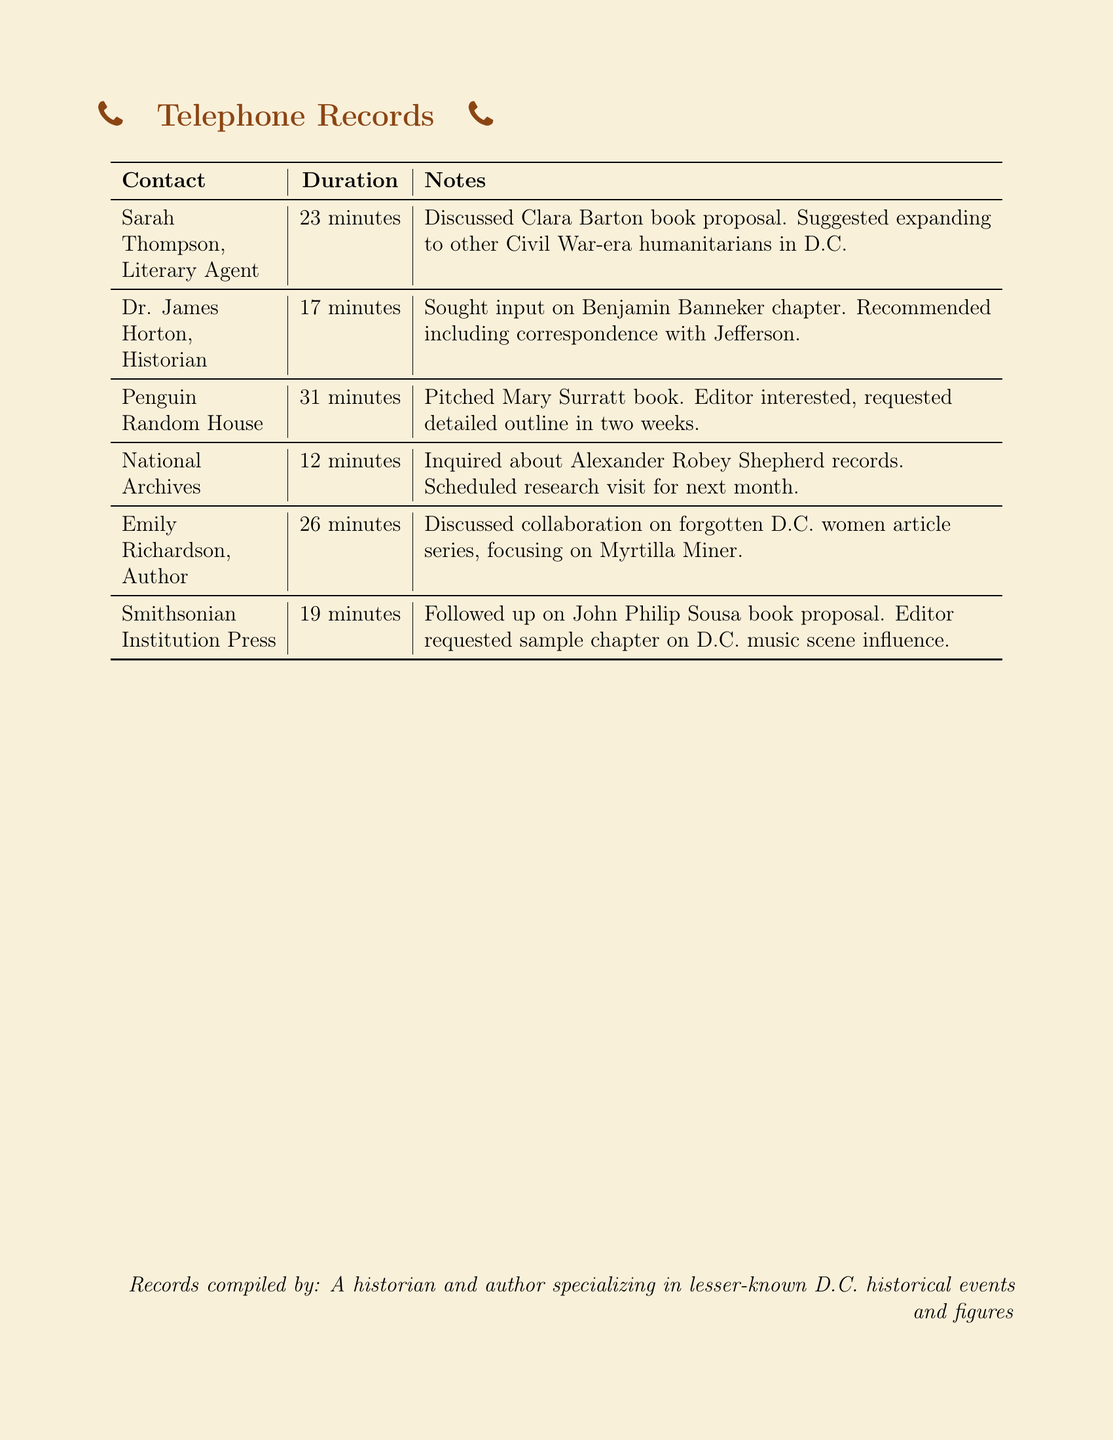What is the duration of the call with Sarah Thompson? The duration for the call with Sarah Thompson is listed in the document.
Answer: 23 minutes Who is the author discussed in the call with Penguin Random House? The document indicates that the author discussed with Penguin Random House is Mary Surratt.
Answer: Mary Surratt What was recommended to include in the Benjamin Banneker chapter? The document states that correspondence with Jefferson was recommended for inclusion in the chapter.
Answer: Correspondence with Jefferson How many minutes were spent discussing the collaboration on the article series? The document provides the duration of the call about the article series, which indicates the length of the conversation.
Answer: 26 minutes What is the contact name associated with the Smithsonian Institution Press? The contact associated with the Smithsonian Institution Press is mentioned in the document.
Answer: Smithsonian Institution Press How many minutes was the call with the National Archives? The document specifies the duration of the call with the National Archives, providing a clear duration.
Answer: 12 minutes What project is associated with Emily Richardson? The document mentions an article series focused on a specific individual with Emily Richardson.
Answer: Forgotten D.C. women article series What is the next step requested by the Penguin Random House editor? The document outlines the request made by the editor during the call for additional materials.
Answer: Detailed outline in two weeks Which historical figure is the focus of the call with Dr. James Horton? The call with Dr. James Horton centers around a specific individual mentioned in the document.
Answer: Benjamin Banneker 